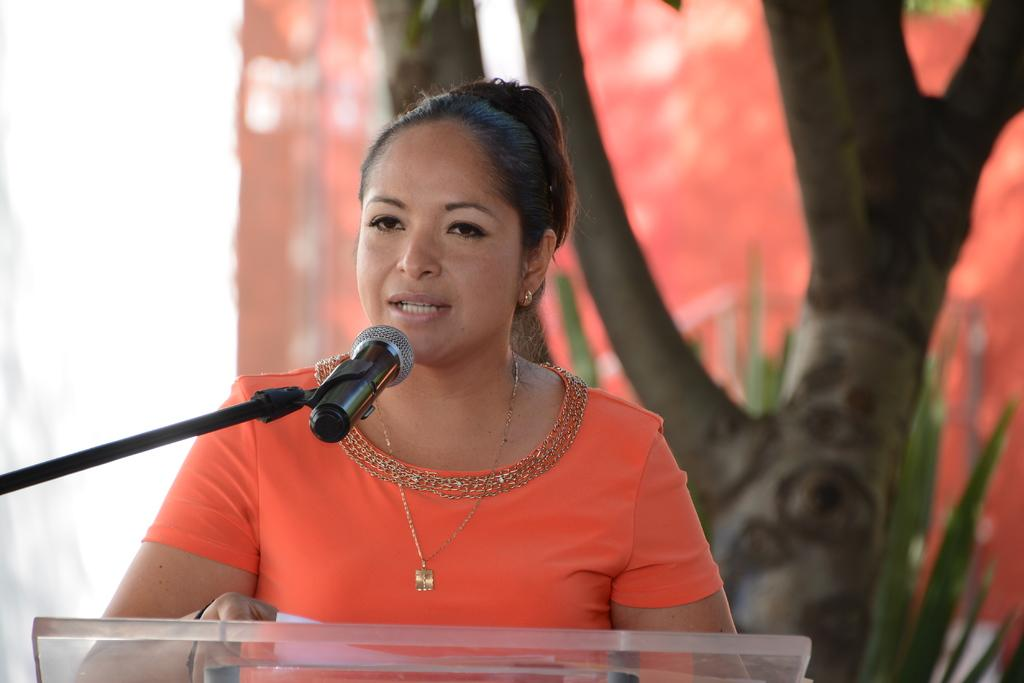Who is the main subject in the image? There is a woman in the image. What is the woman wearing? The woman is wearing an orange dress. What is the woman doing in the image? The woman is speaking in front of a microphone. Can you describe any other elements in the image? There is a tree trunk visible in the image. What type of cloud can be seen in the image? There is no cloud visible in the image; it only features a woman, an orange dress, a microphone, and a tree trunk. Can you describe the romantic interaction between the woman and the tree trunk in the image? There is no romantic interaction between the woman and the tree trunk in the image; the woman is speaking in front of a microphone, and the tree trunk is simply a background element. 